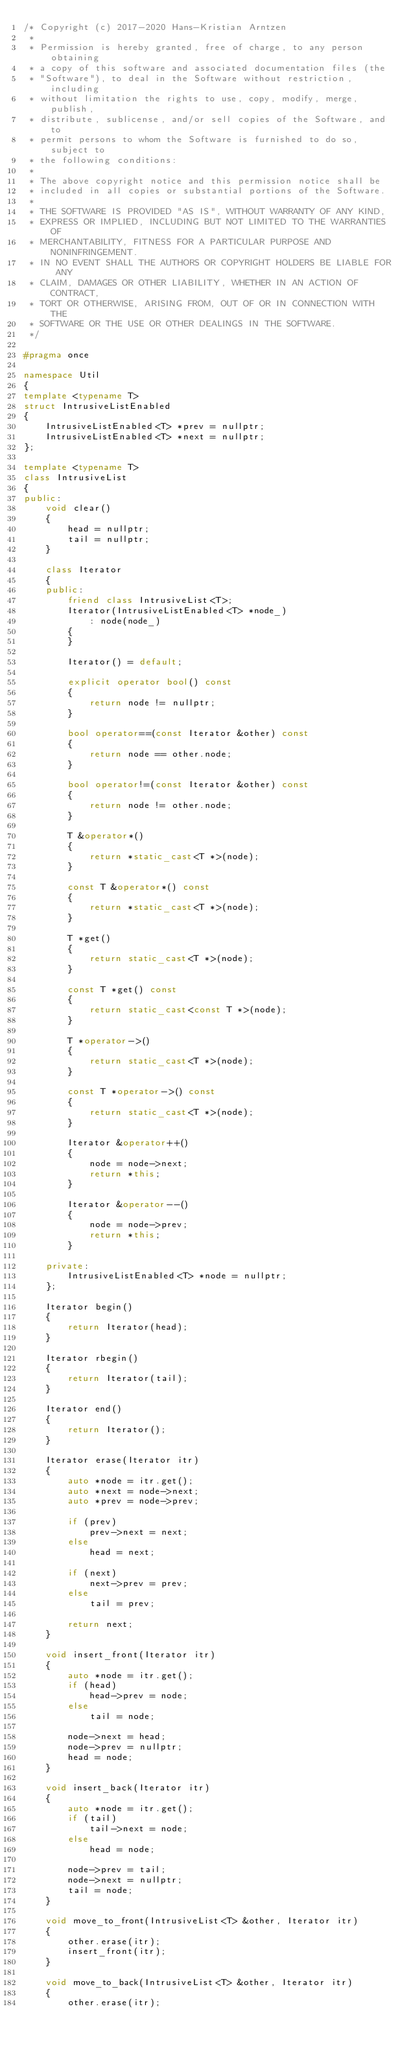<code> <loc_0><loc_0><loc_500><loc_500><_C++_>/* Copyright (c) 2017-2020 Hans-Kristian Arntzen
 *
 * Permission is hereby granted, free of charge, to any person obtaining
 * a copy of this software and associated documentation files (the
 * "Software"), to deal in the Software without restriction, including
 * without limitation the rights to use, copy, modify, merge, publish,
 * distribute, sublicense, and/or sell copies of the Software, and to
 * permit persons to whom the Software is furnished to do so, subject to
 * the following conditions:
 *
 * The above copyright notice and this permission notice shall be
 * included in all copies or substantial portions of the Software.
 *
 * THE SOFTWARE IS PROVIDED "AS IS", WITHOUT WARRANTY OF ANY KIND,
 * EXPRESS OR IMPLIED, INCLUDING BUT NOT LIMITED TO THE WARRANTIES OF
 * MERCHANTABILITY, FITNESS FOR A PARTICULAR PURPOSE AND NONINFRINGEMENT.
 * IN NO EVENT SHALL THE AUTHORS OR COPYRIGHT HOLDERS BE LIABLE FOR ANY
 * CLAIM, DAMAGES OR OTHER LIABILITY, WHETHER IN AN ACTION OF CONTRACT,
 * TORT OR OTHERWISE, ARISING FROM, OUT OF OR IN CONNECTION WITH THE
 * SOFTWARE OR THE USE OR OTHER DEALINGS IN THE SOFTWARE.
 */

#pragma once

namespace Util
{
template <typename T>
struct IntrusiveListEnabled
{
	IntrusiveListEnabled<T> *prev = nullptr;
	IntrusiveListEnabled<T> *next = nullptr;
};

template <typename T>
class IntrusiveList
{
public:
	void clear()
	{
		head = nullptr;
		tail = nullptr;
	}

	class Iterator
	{
	public:
		friend class IntrusiveList<T>;
		Iterator(IntrusiveListEnabled<T> *node_)
		    : node(node_)
		{
		}

		Iterator() = default;

		explicit operator bool() const
		{
			return node != nullptr;
		}

		bool operator==(const Iterator &other) const
		{
			return node == other.node;
		}

		bool operator!=(const Iterator &other) const
		{
			return node != other.node;
		}

		T &operator*()
		{
			return *static_cast<T *>(node);
		}

		const T &operator*() const
		{
			return *static_cast<T *>(node);
		}

		T *get()
		{
			return static_cast<T *>(node);
		}

		const T *get() const
		{
			return static_cast<const T *>(node);
		}

		T *operator->()
		{
			return static_cast<T *>(node);
		}

		const T *operator->() const
		{
			return static_cast<T *>(node);
		}

		Iterator &operator++()
		{
			node = node->next;
			return *this;
		}

		Iterator &operator--()
		{
			node = node->prev;
			return *this;
		}

	private:
		IntrusiveListEnabled<T> *node = nullptr;
	};

	Iterator begin()
	{
		return Iterator(head);
	}

	Iterator rbegin()
	{
		return Iterator(tail);
	}

	Iterator end()
	{
		return Iterator();
	}

	Iterator erase(Iterator itr)
	{
		auto *node = itr.get();
		auto *next = node->next;
		auto *prev = node->prev;

		if (prev)
			prev->next = next;
		else
			head = next;

		if (next)
			next->prev = prev;
		else
			tail = prev;

		return next;
	}

	void insert_front(Iterator itr)
	{
		auto *node = itr.get();
		if (head)
			head->prev = node;
		else
			tail = node;

		node->next = head;
		node->prev = nullptr;
		head = node;
	}

	void insert_back(Iterator itr)
	{
		auto *node = itr.get();
		if (tail)
			tail->next = node;
		else
			head = node;

		node->prev = tail;
		node->next = nullptr;
		tail = node;
	}

	void move_to_front(IntrusiveList<T> &other, Iterator itr)
	{
		other.erase(itr);
		insert_front(itr);
	}

	void move_to_back(IntrusiveList<T> &other, Iterator itr)
	{
		other.erase(itr);</code> 